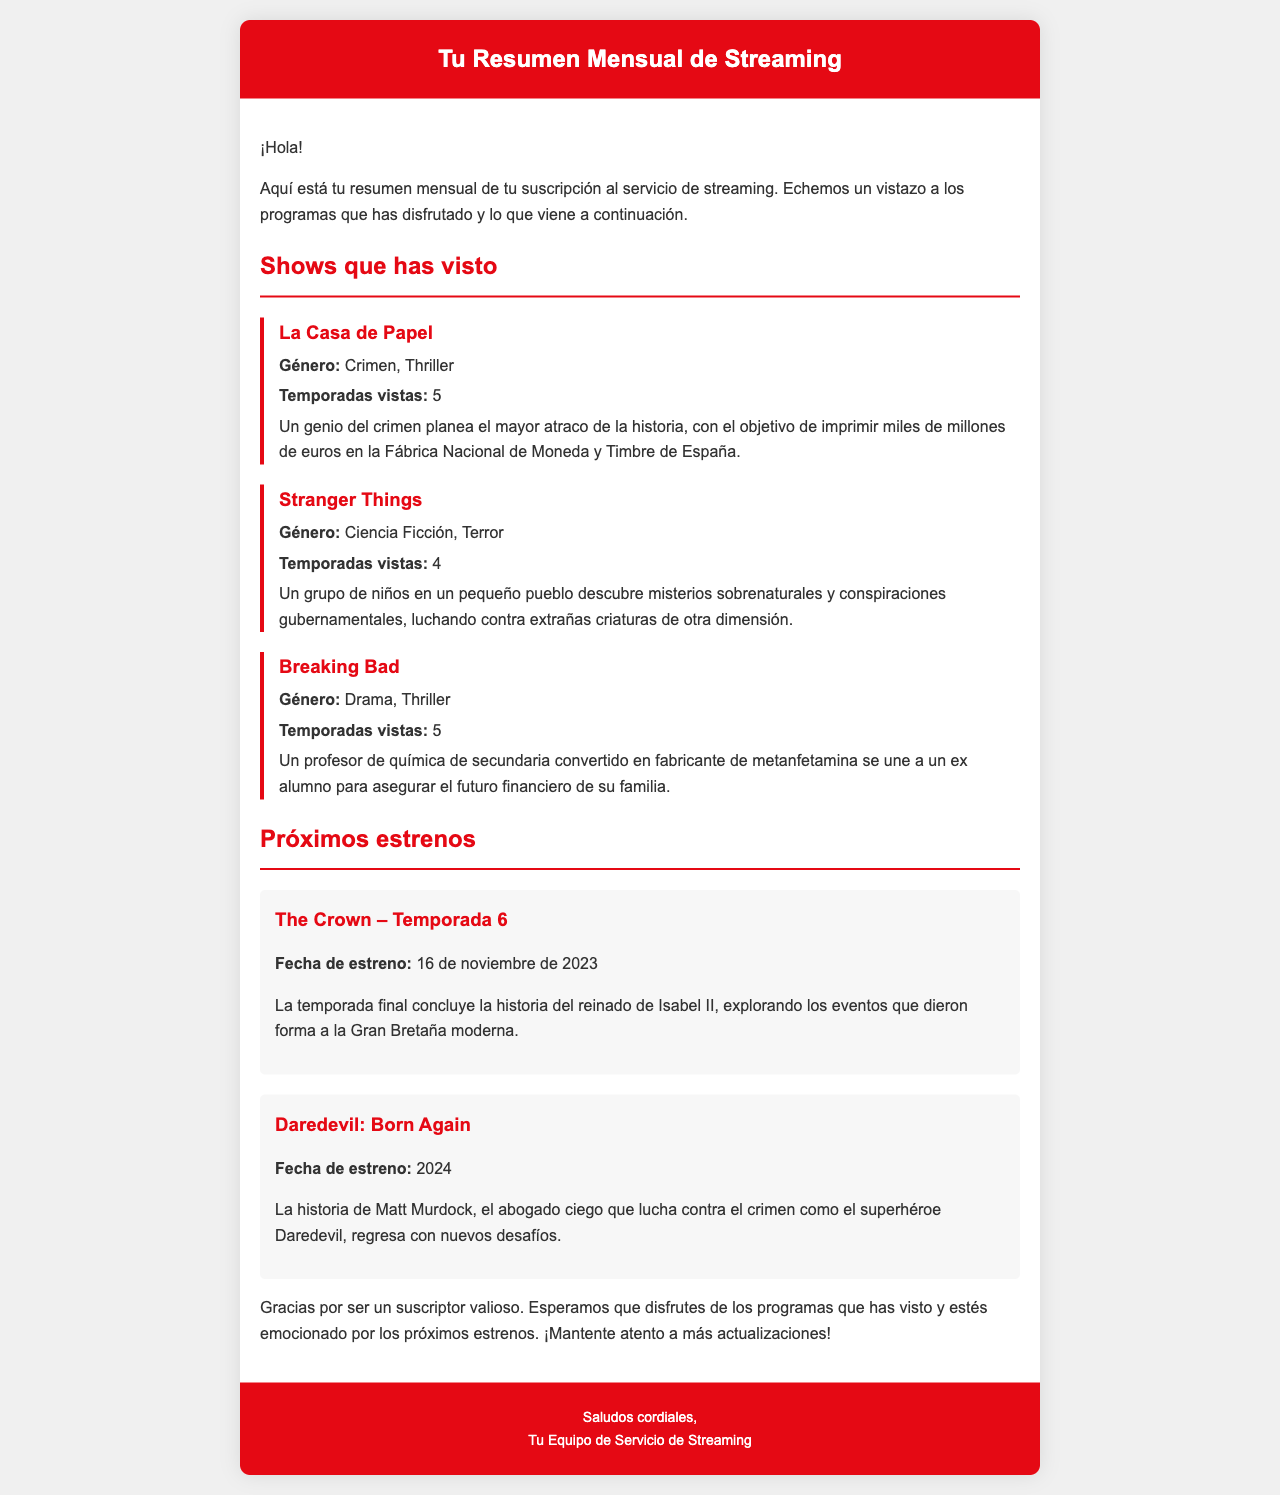¿Cuántas temporadas vistas tiene "La Casa de Papel"? La sección sobre "La Casa de Papel" indica que se han visto 5 temporadas.
Answer: 5 ¿Cuándo se estrena "The Crown – Temporada 6"? El documento menciona que "The Crown – Temporada 6" se estrena el 16 de noviembre de 2023.
Answer: 16 de noviembre de 2023 ¿Cuál es el género de "Stranger Things"? En el resumen se detalla que el género de "Stranger Things" es Ciencia Ficción, Terror.
Answer: Ciencia Ficción, Terror ¿Cómo se llama el protagonista en "Daredevil: Born Again"? El documento menciona que el protagonista es Matt Murdock, quien es un abogado ciego.
Answer: Matt Murdock ¿Cuántos shows se han listado en total? En el resumen se enumeran 3 shows vistos y 2 próximos estrenos, lo que suma un total de 5 shows.
Answer: 5 ¿Qué programa se describe como un genio del crimen? La descripción de "La Casa de Papel" menciona que el protagonista es un genio del crimen.
Answer: La Casa de Papel ¿Cuántas temporadas tienes de "Breaking Bad"? El documento indica que se han visto 5 temporadas de "Breaking Bad".
Answer: 5 ¿Qué tema aborda "The Crown – Temporada 6"? Se menciona que la temporada final concluye la historia del reinado de Isabel II.
Answer: Reinado de Isabel II 